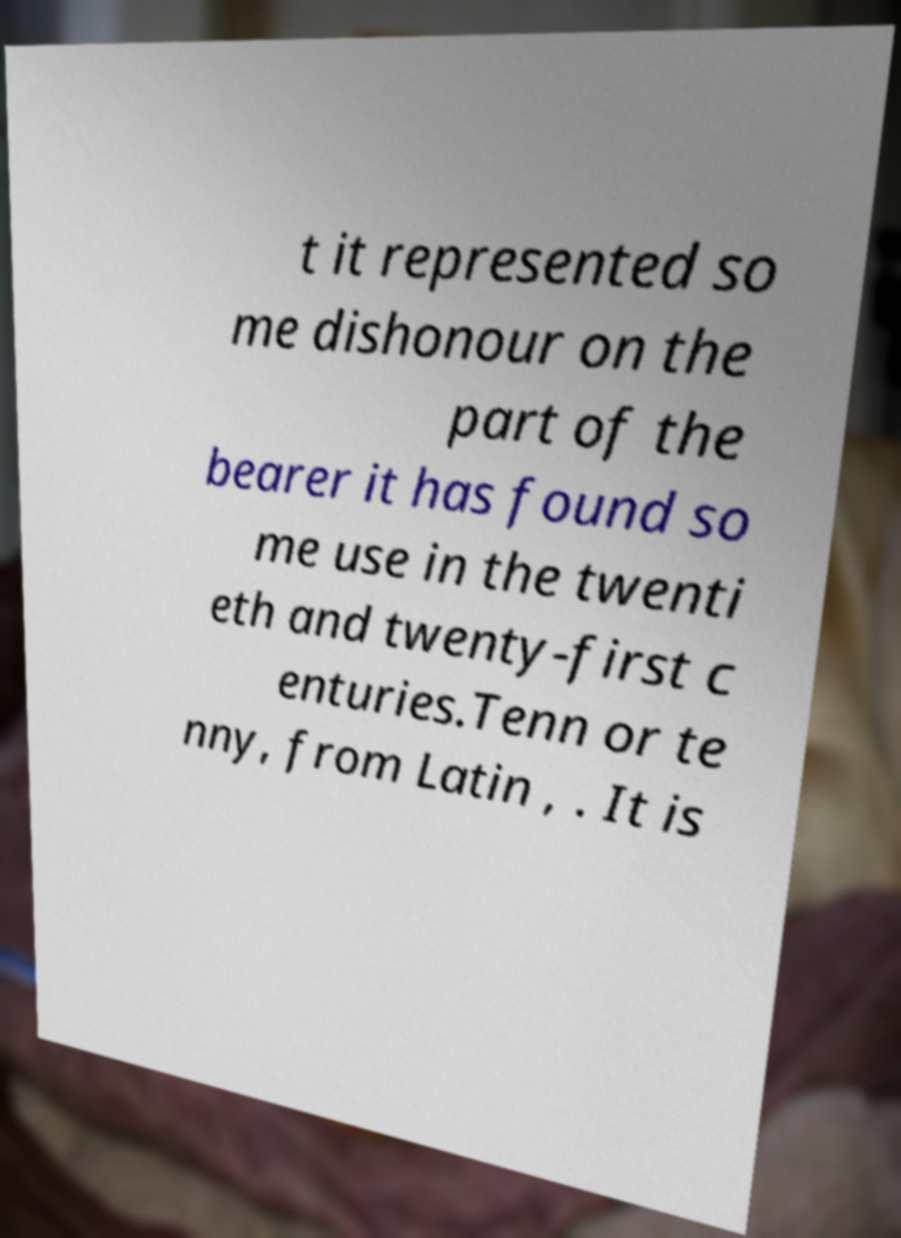I need the written content from this picture converted into text. Can you do that? t it represented so me dishonour on the part of the bearer it has found so me use in the twenti eth and twenty-first c enturies.Tenn or te nny, from Latin , . It is 